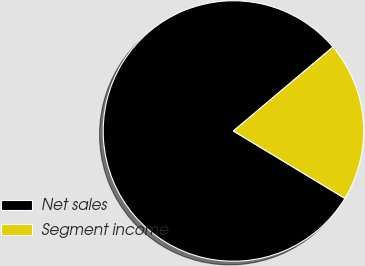Convert chart. <chart><loc_0><loc_0><loc_500><loc_500><pie_chart><fcel>Net sales<fcel>Segment income<nl><fcel>80.2%<fcel>19.8%<nl></chart> 